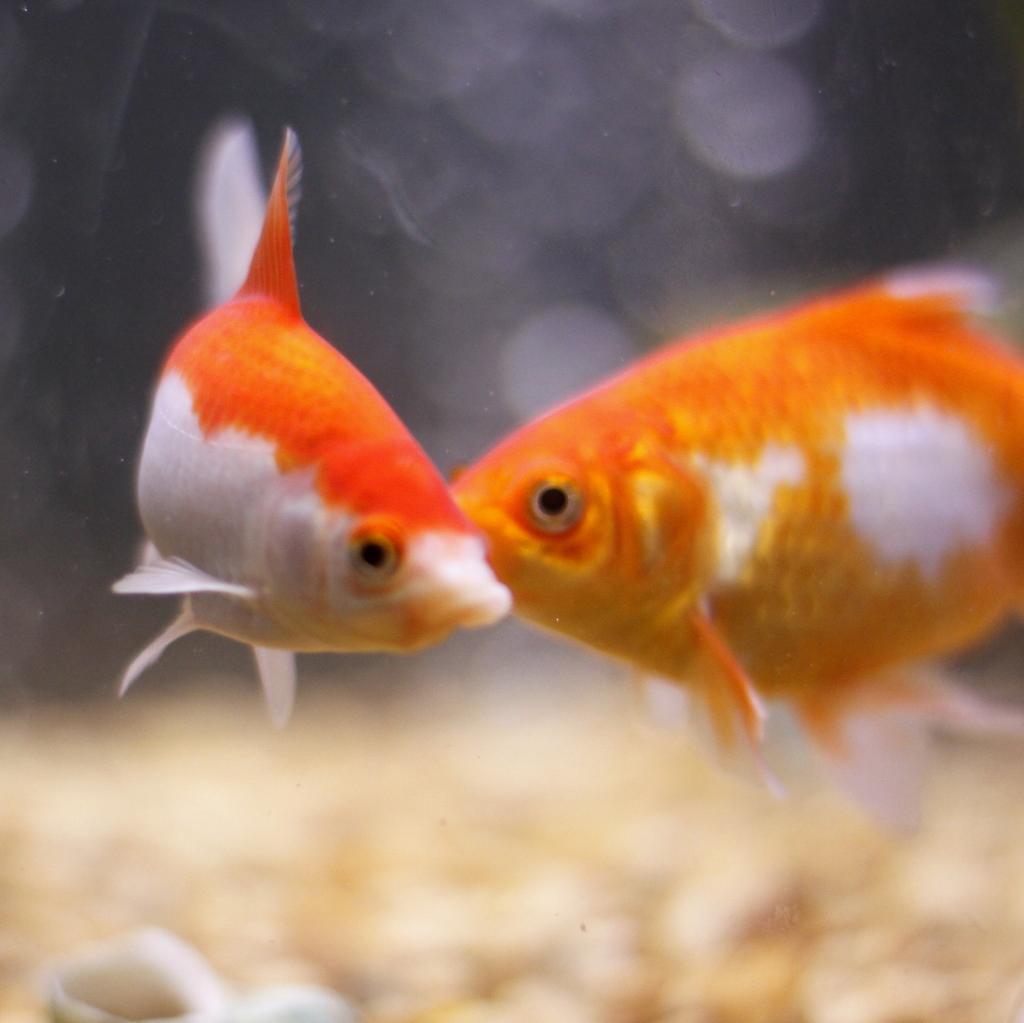Could you give a brief overview of what you see in this image? In this image I can see two fishes, they are in orange and white color. 